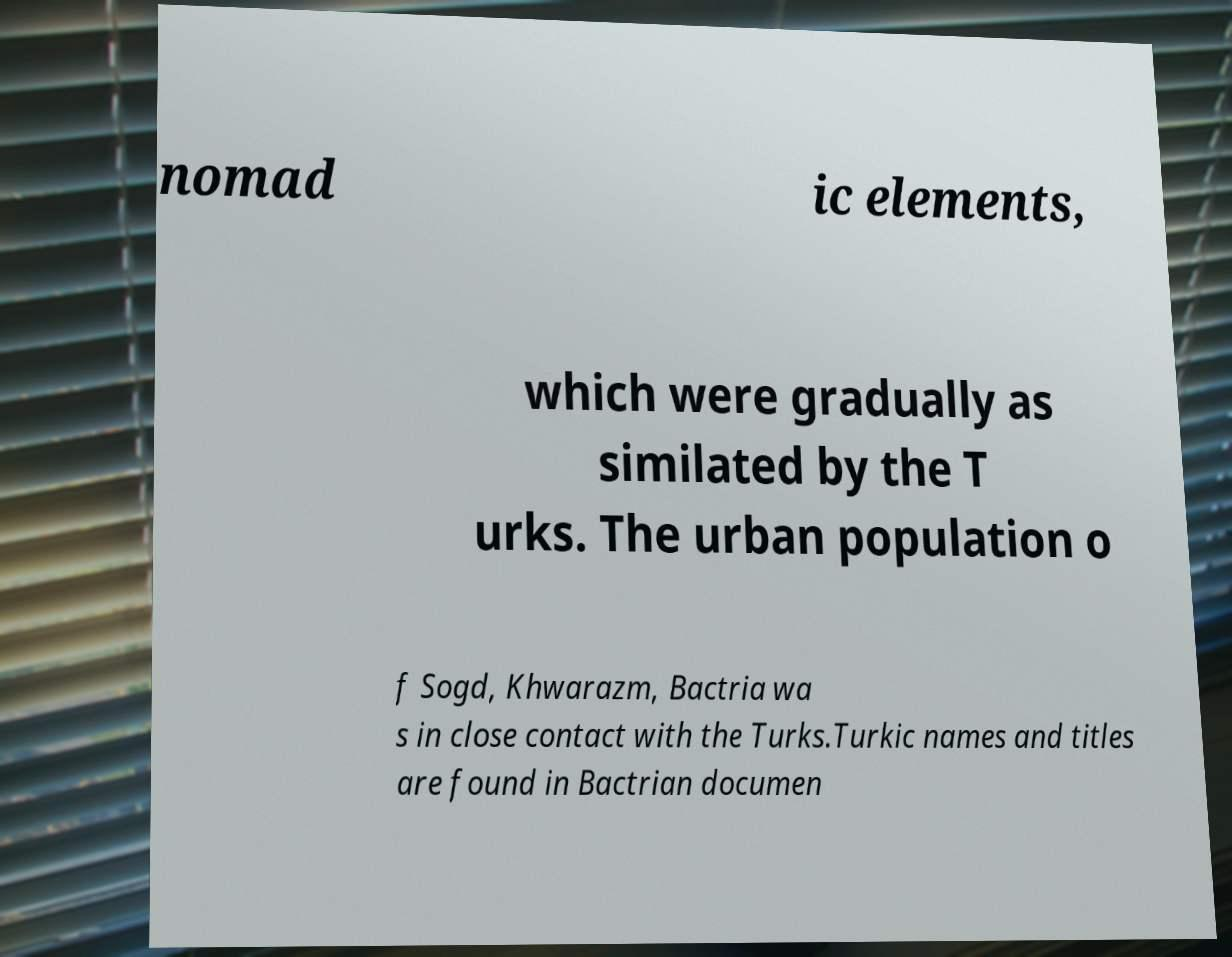Could you extract and type out the text from this image? nomad ic elements, which were gradually as similated by the T urks. The urban population o f Sogd, Khwarazm, Bactria wa s in close contact with the Turks.Turkic names and titles are found in Bactrian documen 